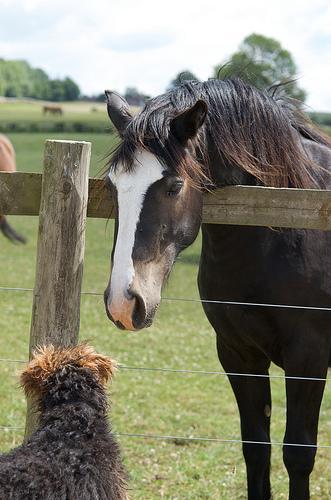How many dogs are there?
Give a very brief answer. 1. 